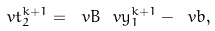<formula> <loc_0><loc_0><loc_500><loc_500>\ v t _ { 2 } ^ { k + 1 } = \ v B \ v y _ { 1 } ^ { k + 1 } - \ v b ,</formula> 